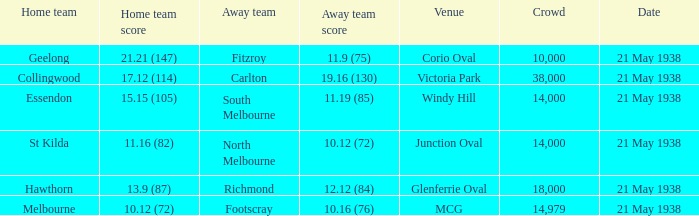Which Home team has a Venue of mcg? Melbourne. 